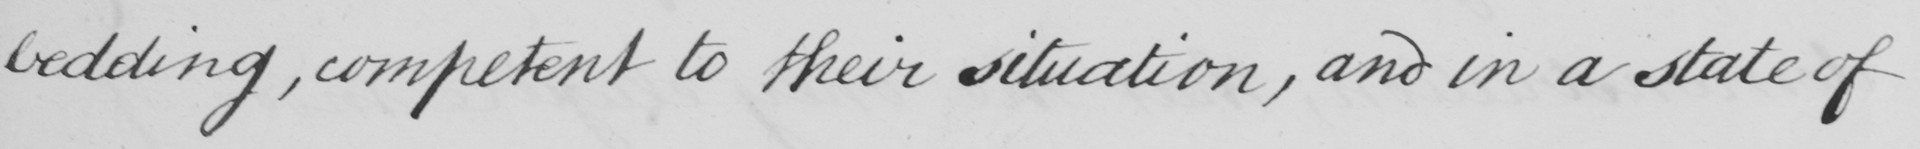Please provide the text content of this handwritten line. bedding, competent to their situation, and in a state of 